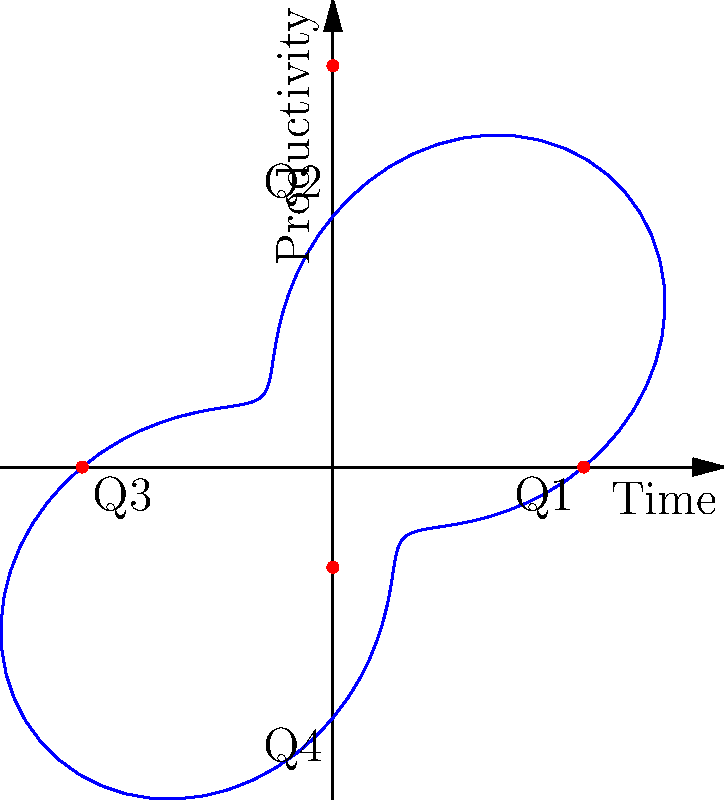In the polar coordinate graph representing quarterly productivity fluctuations, what is the maximum radial distance from the origin, and in which quarter does it occur? To solve this problem, let's follow these steps:

1. The polar function given is $r(\theta) = 5 + 3\sin(2\theta)$, where $r$ is the radial distance and $\theta$ is the angle.

2. The maximum radial distance will occur when $\sin(2\theta)$ is at its maximum value of 1.

3. To find when this occurs, we need to solve:
   $2\theta = \frac{\pi}{2} + 2\pi n$, where $n$ is an integer.

4. Solving for $\theta$:
   $\theta = \frac{\pi}{4} + \pi n$

5. The first positive solution (corresponding to the first quarter) is when $n=0$:
   $\theta = \frac{\pi}{4}$

6. This angle corresponds to the middle of Q1 (first quarter).

7. The maximum radial distance is:
   $r_{max} = 5 + 3\sin(2 \cdot \frac{\pi}{4}) = 5 + 3 = 8$

Therefore, the maximum radial distance is 8 units and it occurs in Q1.
Answer: 8 units in Q1 